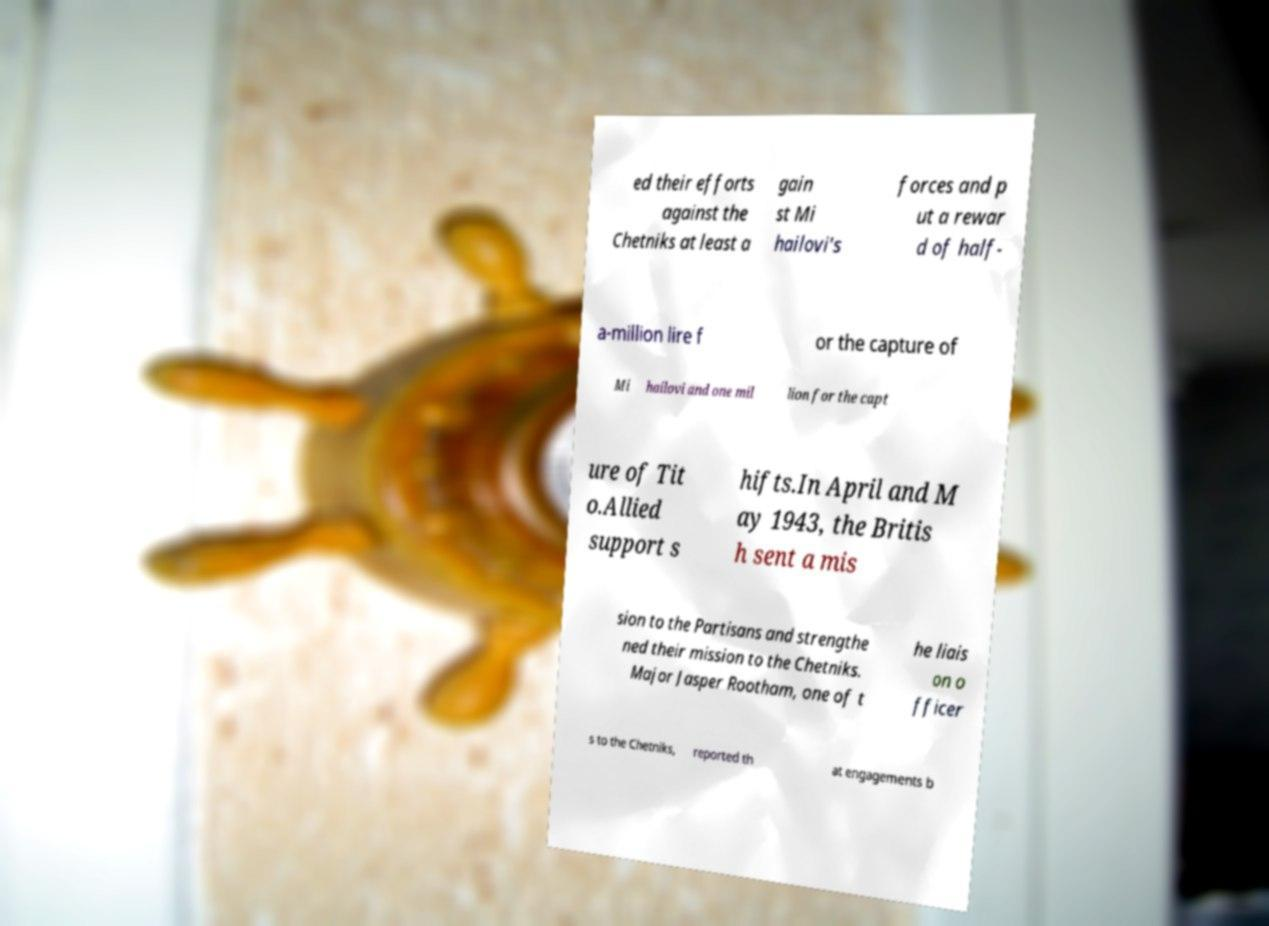Could you extract and type out the text from this image? ed their efforts against the Chetniks at least a gain st Mi hailovi's forces and p ut a rewar d of half- a-million lire f or the capture of Mi hailovi and one mil lion for the capt ure of Tit o.Allied support s hifts.In April and M ay 1943, the Britis h sent a mis sion to the Partisans and strengthe ned their mission to the Chetniks. Major Jasper Rootham, one of t he liais on o fficer s to the Chetniks, reported th at engagements b 